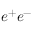<formula> <loc_0><loc_0><loc_500><loc_500>e ^ { + } e ^ { - }</formula> 